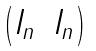Convert formula to latex. <formula><loc_0><loc_0><loc_500><loc_500>\begin{pmatrix} I _ { n } & I _ { n } \end{pmatrix}</formula> 